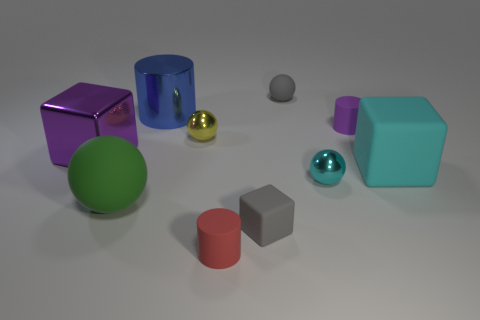Subtract all cyan cylinders. Subtract all brown spheres. How many cylinders are left? 3 Subtract all cubes. How many objects are left? 7 Add 6 yellow objects. How many yellow objects are left? 7 Add 6 red matte objects. How many red matte objects exist? 7 Subtract 0 brown cylinders. How many objects are left? 10 Subtract all tiny matte things. Subtract all red cylinders. How many objects are left? 5 